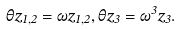Convert formula to latex. <formula><loc_0><loc_0><loc_500><loc_500>\theta z _ { 1 , 2 } = \omega z _ { 1 , 2 } , \theta z _ { 3 } = \omega ^ { 3 } z _ { 3 } .</formula> 